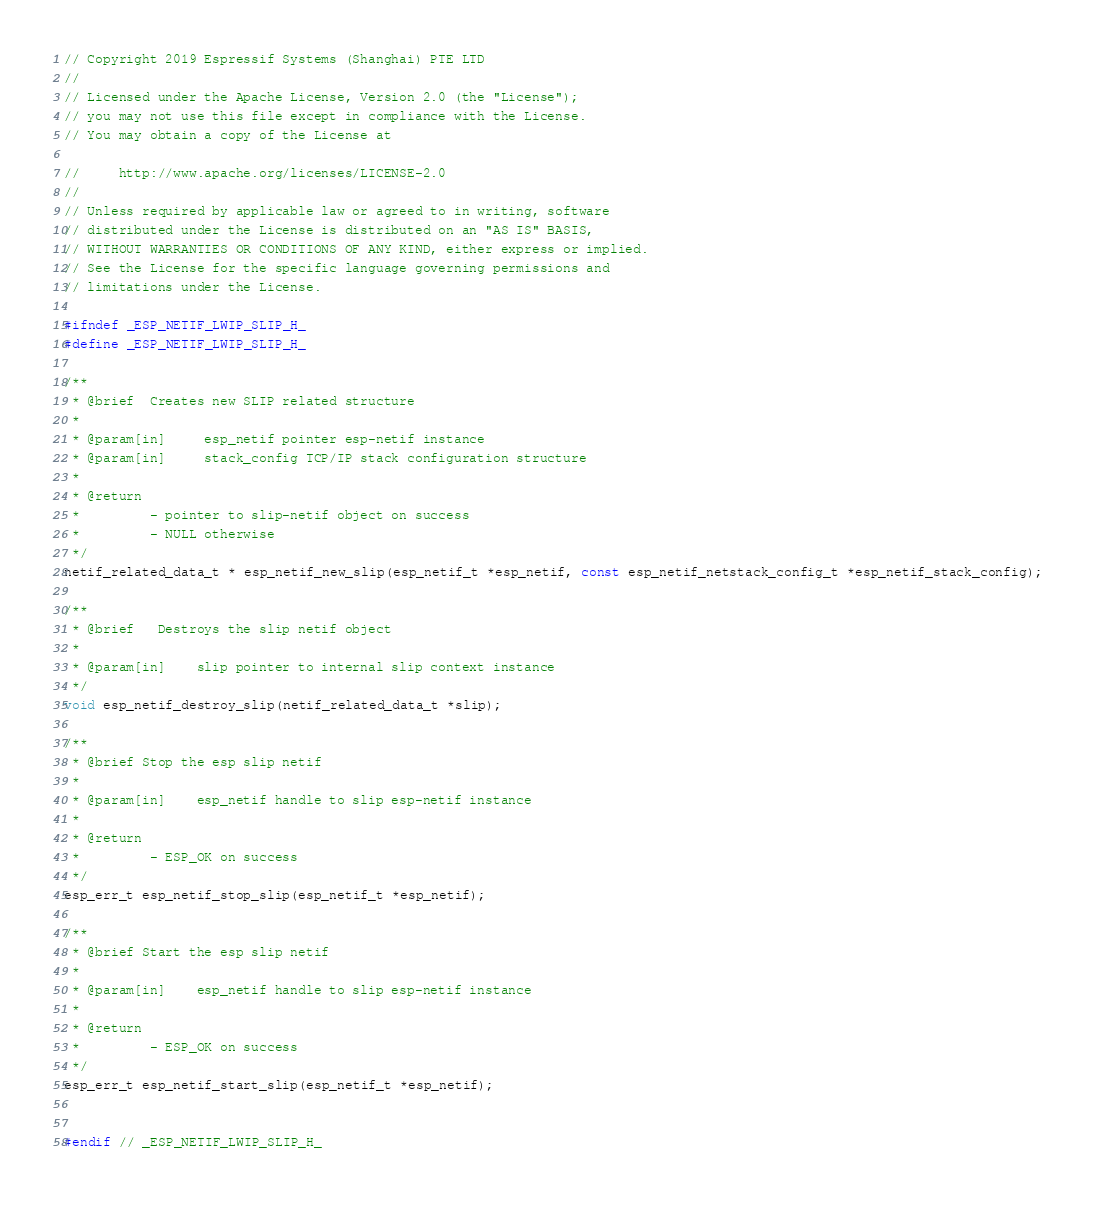Convert code to text. <code><loc_0><loc_0><loc_500><loc_500><_C_>// Copyright 2019 Espressif Systems (Shanghai) PTE LTD
//
// Licensed under the Apache License, Version 2.0 (the "License");
// you may not use this file except in compliance with the License.
// You may obtain a copy of the License at

//     http://www.apache.org/licenses/LICENSE-2.0
//
// Unless required by applicable law or agreed to in writing, software
// distributed under the License is distributed on an "AS IS" BASIS,
// WITHOUT WARRANTIES OR CONDITIONS OF ANY KIND, either express or implied.
// See the License for the specific language governing permissions and
// limitations under the License.

#ifndef _ESP_NETIF_LWIP_SLIP_H_
#define _ESP_NETIF_LWIP_SLIP_H_

/**
 * @brief  Creates new SLIP related structure
 *
 * @param[in]     esp_netif pointer esp-netif instance
 * @param[in]     stack_config TCP/IP stack configuration structure
 *
 * @return
 *         - pointer to slip-netif object on success
 *         - NULL otherwise
 */
netif_related_data_t * esp_netif_new_slip(esp_netif_t *esp_netif, const esp_netif_netstack_config_t *esp_netif_stack_config);

/**
 * @brief   Destroys the slip netif object
 *
 * @param[in]    slip pointer to internal slip context instance
 */
void esp_netif_destroy_slip(netif_related_data_t *slip);

/**
 * @brief Stop the esp slip netif
 *
 * @param[in]    esp_netif handle to slip esp-netif instance
 *
 * @return
 *         - ESP_OK on success
 */
esp_err_t esp_netif_stop_slip(esp_netif_t *esp_netif);

/**
 * @brief Start the esp slip netif
 *
 * @param[in]    esp_netif handle to slip esp-netif instance
 *
 * @return
 *         - ESP_OK on success
 */
esp_err_t esp_netif_start_slip(esp_netif_t *esp_netif);


#endif // _ESP_NETIF_LWIP_SLIP_H_
</code> 